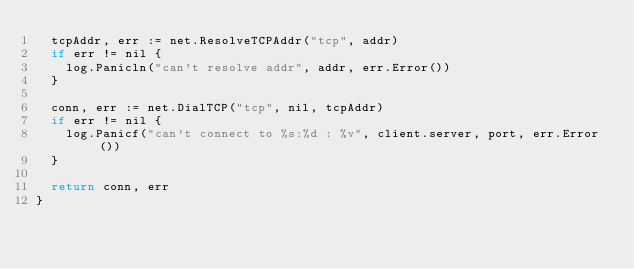Convert code to text. <code><loc_0><loc_0><loc_500><loc_500><_Go_>	tcpAddr, err := net.ResolveTCPAddr("tcp", addr)
	if err != nil {
		log.Panicln("can't resolve addr", addr, err.Error())
	}

	conn, err := net.DialTCP("tcp", nil, tcpAddr)
	if err != nil {
		log.Panicf("can't connect to %s:%d : %v", client.server, port, err.Error())
	}

	return conn, err
}
</code> 